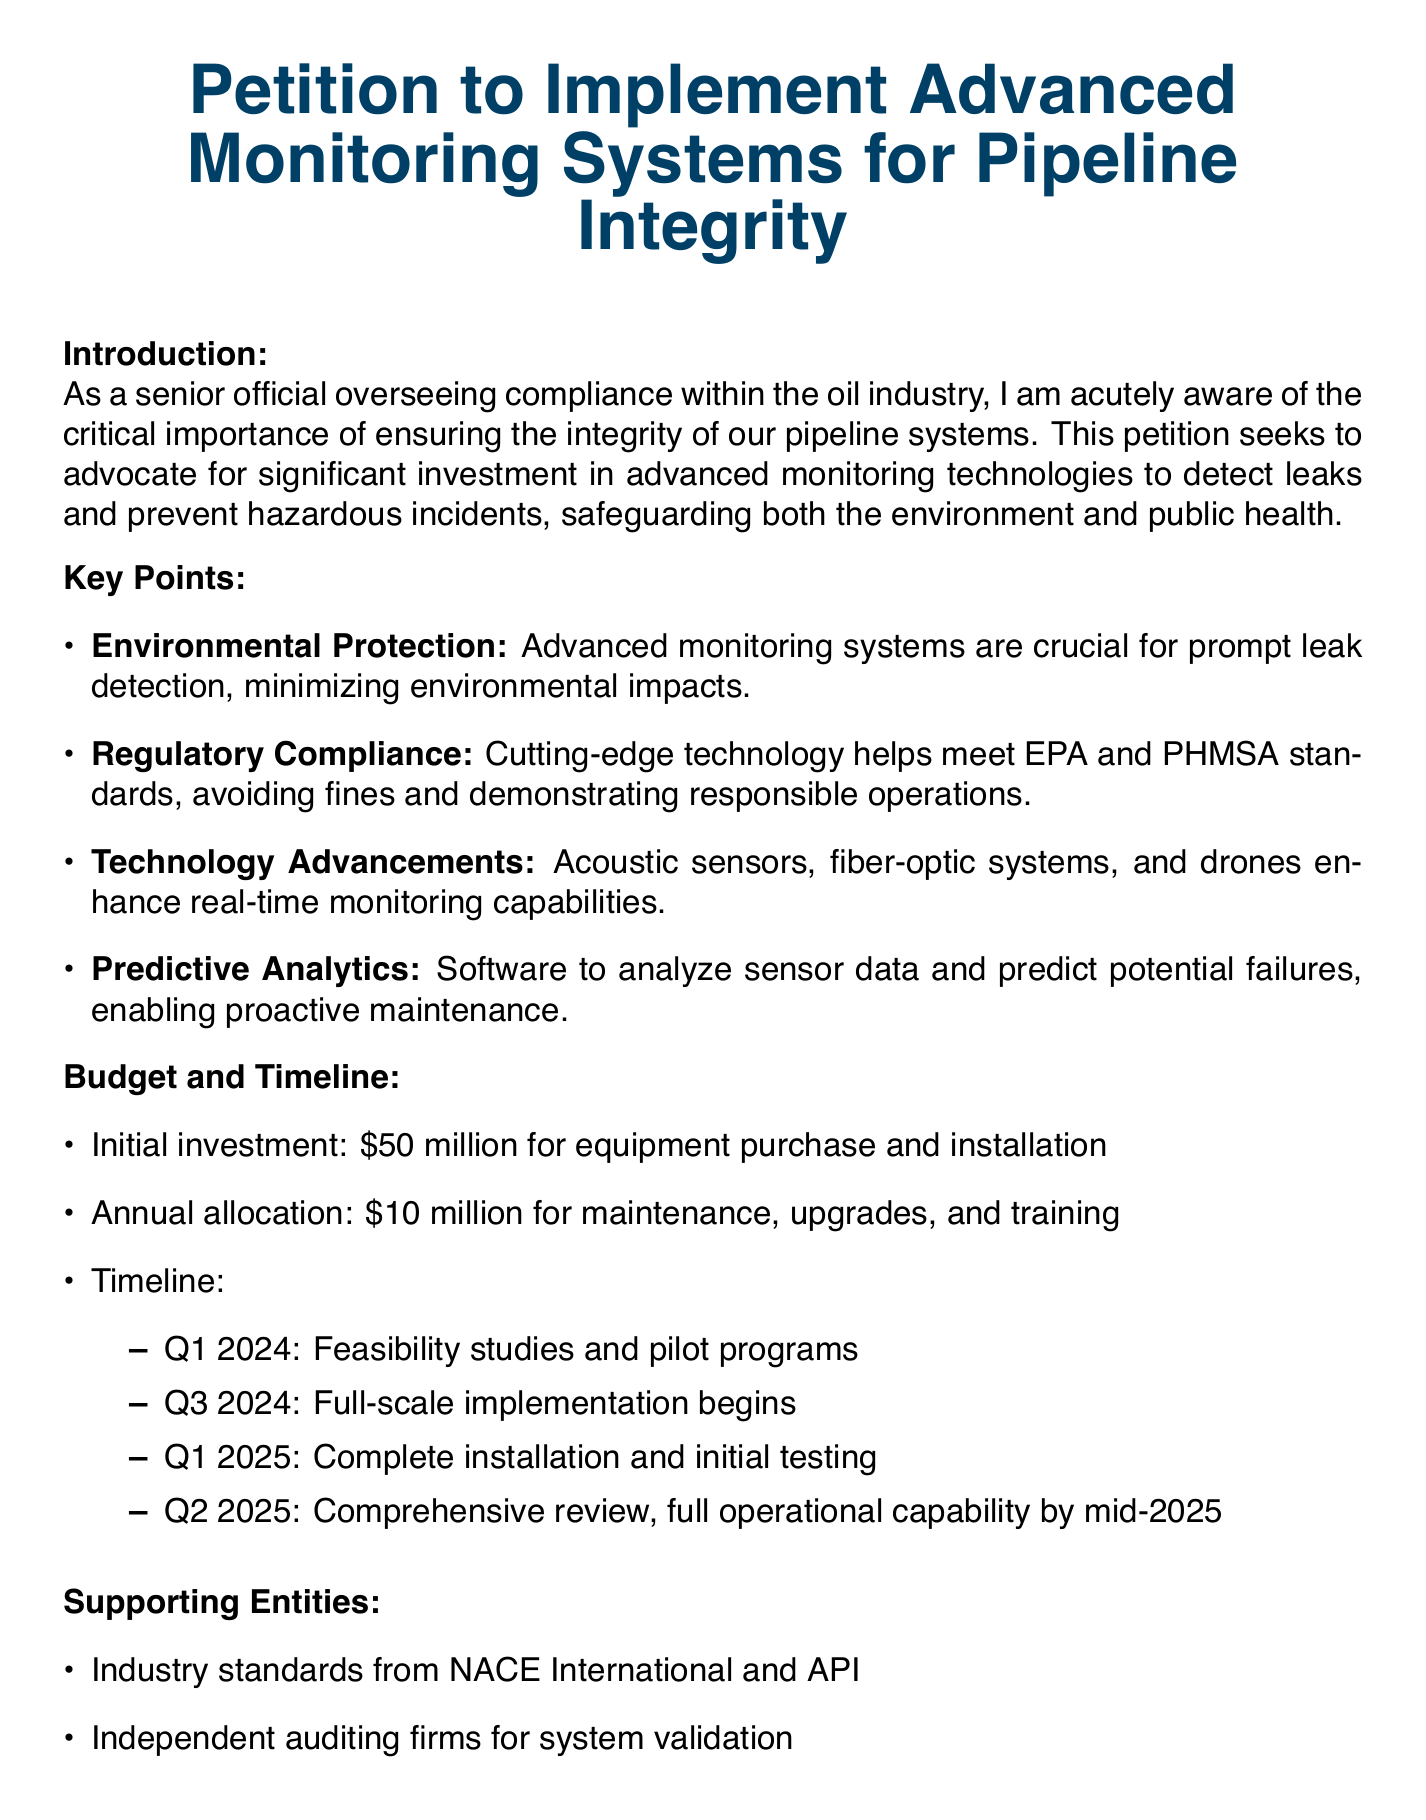What is the initial investment requested? The initial investment requested for equipment purchase and installation is specified in the budget section of the document.
Answer: $50 million What is the projected timeline for full-scale implementation? The document outlines the timeline for full-scale implementation within the budget and timeline section.
Answer: Q3 2024 Which entities endorse the proposal? The supporting entities that validate the petition are mentioned in the supporting entities section of the document.
Answer: NACE International and API How much is allocated annually for maintenance? The document specifies the annual allocation for maintenance as part of the budget information provided.
Answer: $10 million What technology is mentioned for real-time monitoring? The document lists various technologies under the key points discussing technology advancements.
Answer: Acoustic sensors, fiber-optic systems, and drones When is the feasibility study scheduled to commence? The timeline section of the document specifies when feasibility studies are set to begin.
Answer: Q1 2024 What is the purpose of implementing advanced monitoring systems? The introduction section outlines the main goals and rationale behind the petition.
Answer: Prevent hazardous incidents What is the primary goal of the petition? The introduction summarizes the key objectives of the petition to address pipeline integrity.
Answer: Safeguarding both the environment and public health 